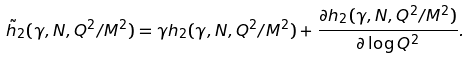Convert formula to latex. <formula><loc_0><loc_0><loc_500><loc_500>\tilde { h } _ { 2 } ( \gamma , N , Q ^ { 2 } / M ^ { 2 } ) = \gamma h _ { 2 } ( \gamma , N , Q ^ { 2 } / M ^ { 2 } ) + \frac { \partial h _ { 2 } ( \gamma , N , Q ^ { 2 } / M ^ { 2 } ) } { \partial \log { Q ^ { 2 } } } .</formula> 